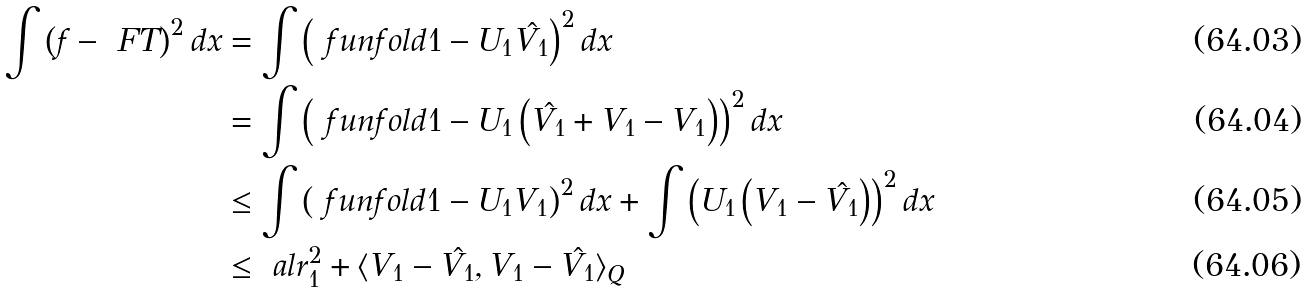<formula> <loc_0><loc_0><loc_500><loc_500>\int \left ( f - \ F T \right ) ^ { 2 } d x & = \int \left ( \ f u n f o l d { 1 } - U _ { 1 } \hat { V _ { 1 } } \right ) ^ { 2 } d x \\ & = \int \left ( \ f u n f o l d { 1 } - U _ { 1 } \left ( \hat { V _ { 1 } } + V _ { 1 } - V _ { 1 } \right ) \right ) ^ { 2 } d x \\ & \leq \int \left ( \ f u n f o l d { 1 } - U _ { 1 } V _ { 1 } \right ) ^ { 2 } d x + \int \left ( U _ { 1 } \left ( V _ { 1 } - \hat { V _ { 1 } } \right ) \right ) ^ { 2 } d x \\ & \leq \ a l r _ { 1 } ^ { 2 } + \langle V _ { 1 } - \hat { V _ { 1 } } , V _ { 1 } - \hat { V _ { 1 } } \rangle _ { Q }</formula> 